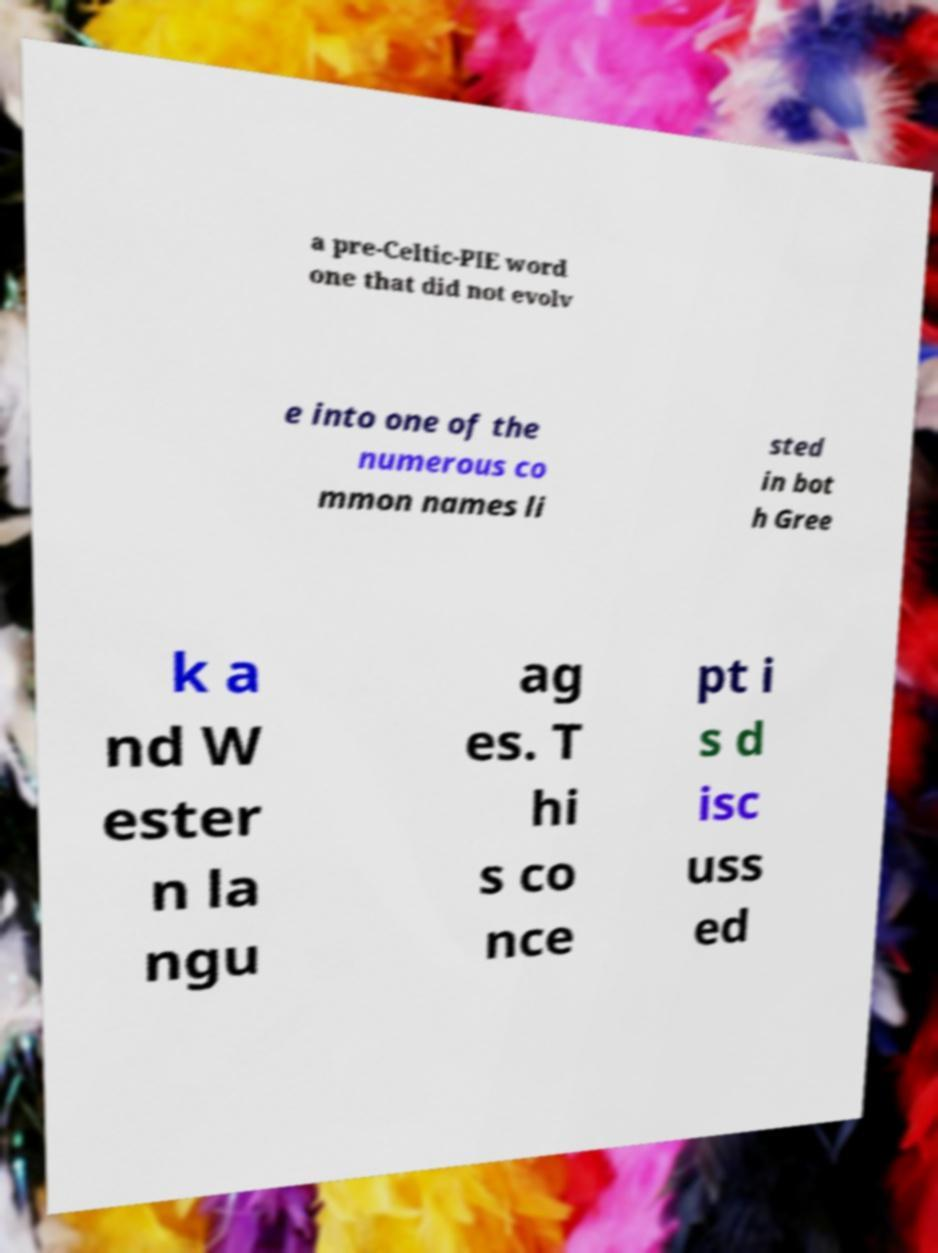Can you read and provide the text displayed in the image?This photo seems to have some interesting text. Can you extract and type it out for me? a pre-Celtic-PIE word one that did not evolv e into one of the numerous co mmon names li sted in bot h Gree k a nd W ester n la ngu ag es. T hi s co nce pt i s d isc uss ed 